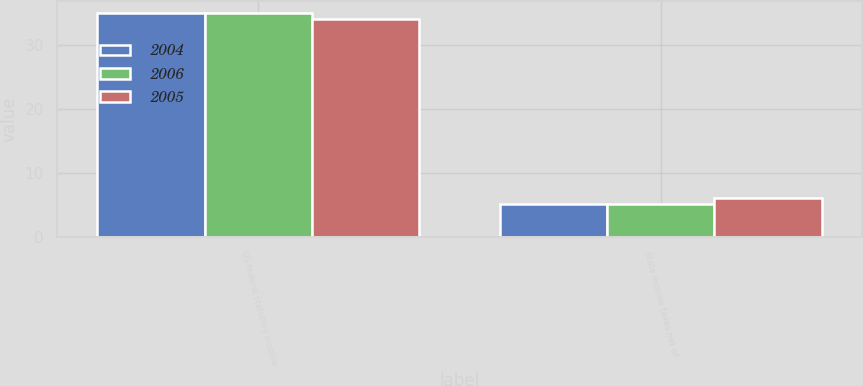Convert chart. <chart><loc_0><loc_0><loc_500><loc_500><stacked_bar_chart><ecel><fcel>US federal statutory income<fcel>State income taxes net of<nl><fcel>2004<fcel>35<fcel>5.15<nl><fcel>2006<fcel>35<fcel>5.14<nl><fcel>2005<fcel>34<fcel>6<nl></chart> 